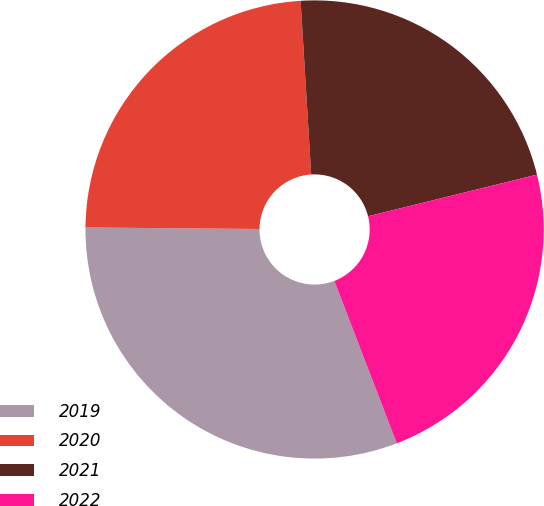<chart> <loc_0><loc_0><loc_500><loc_500><pie_chart><fcel>2019<fcel>2020<fcel>2021<fcel>2022<nl><fcel>30.98%<fcel>23.89%<fcel>22.12%<fcel>23.01%<nl></chart> 